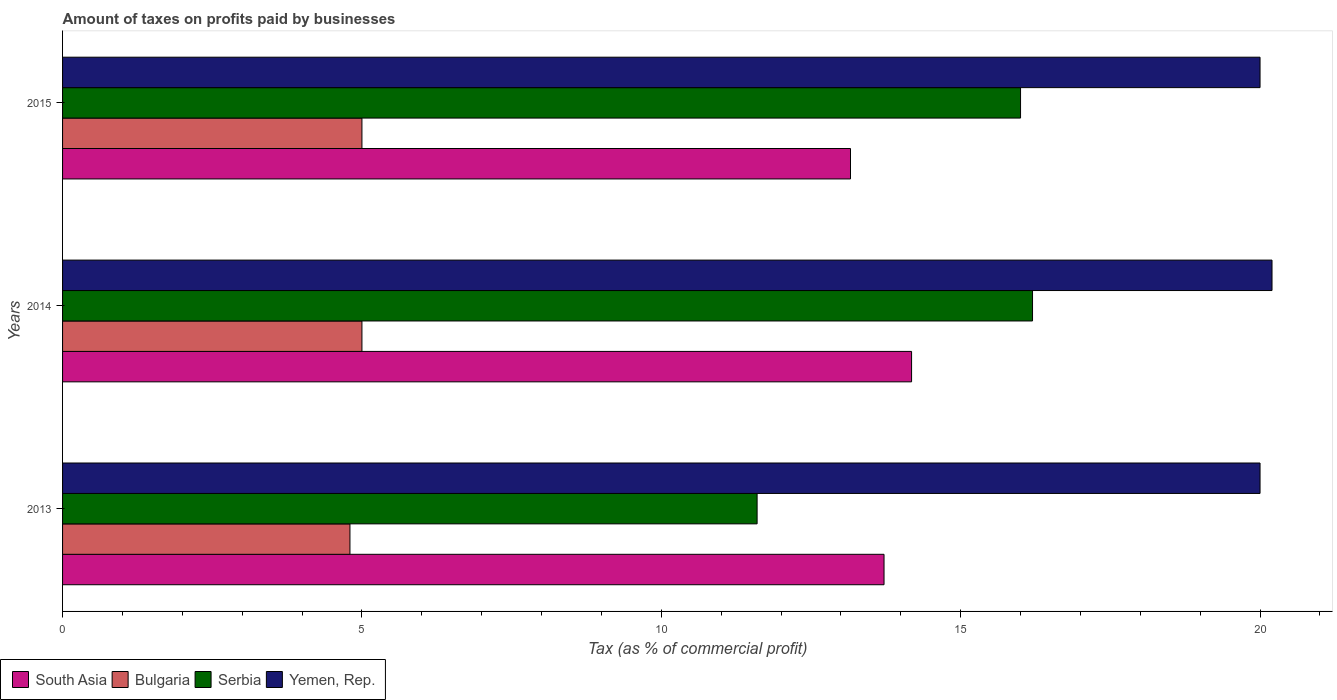How many different coloured bars are there?
Your response must be concise. 4. What is the label of the 1st group of bars from the top?
Ensure brevity in your answer.  2015. In how many cases, is the number of bars for a given year not equal to the number of legend labels?
Make the answer very short. 0. Across all years, what is the maximum percentage of taxes paid by businesses in Yemen, Rep.?
Your answer should be compact. 20.2. In which year was the percentage of taxes paid by businesses in South Asia minimum?
Make the answer very short. 2015. What is the difference between the percentage of taxes paid by businesses in Serbia in 2014 and that in 2015?
Your response must be concise. 0.2. What is the difference between the percentage of taxes paid by businesses in South Asia in 2014 and the percentage of taxes paid by businesses in Bulgaria in 2015?
Your response must be concise. 9.18. What is the average percentage of taxes paid by businesses in South Asia per year?
Give a very brief answer. 13.69. In the year 2013, what is the difference between the percentage of taxes paid by businesses in Serbia and percentage of taxes paid by businesses in South Asia?
Ensure brevity in your answer.  -2.12. What is the ratio of the percentage of taxes paid by businesses in Serbia in 2013 to that in 2014?
Make the answer very short. 0.72. Is the percentage of taxes paid by businesses in Bulgaria in 2013 less than that in 2014?
Your answer should be very brief. Yes. Is the difference between the percentage of taxes paid by businesses in Serbia in 2013 and 2015 greater than the difference between the percentage of taxes paid by businesses in South Asia in 2013 and 2015?
Your answer should be compact. No. What is the difference between the highest and the second highest percentage of taxes paid by businesses in South Asia?
Give a very brief answer. 0.46. What is the difference between the highest and the lowest percentage of taxes paid by businesses in Bulgaria?
Offer a very short reply. 0.2. In how many years, is the percentage of taxes paid by businesses in Bulgaria greater than the average percentage of taxes paid by businesses in Bulgaria taken over all years?
Keep it short and to the point. 2. Is the sum of the percentage of taxes paid by businesses in South Asia in 2013 and 2015 greater than the maximum percentage of taxes paid by businesses in Bulgaria across all years?
Offer a terse response. Yes. Is it the case that in every year, the sum of the percentage of taxes paid by businesses in South Asia and percentage of taxes paid by businesses in Bulgaria is greater than the sum of percentage of taxes paid by businesses in Serbia and percentage of taxes paid by businesses in Yemen, Rep.?
Offer a terse response. No. What does the 4th bar from the top in 2015 represents?
Make the answer very short. South Asia. What does the 2nd bar from the bottom in 2015 represents?
Keep it short and to the point. Bulgaria. Are all the bars in the graph horizontal?
Keep it short and to the point. Yes. How many years are there in the graph?
Give a very brief answer. 3. What is the difference between two consecutive major ticks on the X-axis?
Keep it short and to the point. 5. Does the graph contain any zero values?
Offer a very short reply. No. Where does the legend appear in the graph?
Provide a succinct answer. Bottom left. How are the legend labels stacked?
Offer a terse response. Horizontal. What is the title of the graph?
Offer a very short reply. Amount of taxes on profits paid by businesses. Does "Hungary" appear as one of the legend labels in the graph?
Make the answer very short. No. What is the label or title of the X-axis?
Provide a succinct answer. Tax (as % of commercial profit). What is the label or title of the Y-axis?
Ensure brevity in your answer.  Years. What is the Tax (as % of commercial profit) of South Asia in 2013?
Keep it short and to the point. 13.72. What is the Tax (as % of commercial profit) in Serbia in 2013?
Ensure brevity in your answer.  11.6. What is the Tax (as % of commercial profit) of South Asia in 2014?
Offer a terse response. 14.18. What is the Tax (as % of commercial profit) of Yemen, Rep. in 2014?
Make the answer very short. 20.2. What is the Tax (as % of commercial profit) in South Asia in 2015?
Ensure brevity in your answer.  13.16. What is the Tax (as % of commercial profit) in Bulgaria in 2015?
Make the answer very short. 5. Across all years, what is the maximum Tax (as % of commercial profit) of South Asia?
Your answer should be compact. 14.18. Across all years, what is the maximum Tax (as % of commercial profit) in Yemen, Rep.?
Keep it short and to the point. 20.2. Across all years, what is the minimum Tax (as % of commercial profit) of South Asia?
Keep it short and to the point. 13.16. What is the total Tax (as % of commercial profit) of South Asia in the graph?
Provide a short and direct response. 41.06. What is the total Tax (as % of commercial profit) of Serbia in the graph?
Make the answer very short. 43.8. What is the total Tax (as % of commercial profit) in Yemen, Rep. in the graph?
Offer a very short reply. 60.2. What is the difference between the Tax (as % of commercial profit) of South Asia in 2013 and that in 2014?
Keep it short and to the point. -0.46. What is the difference between the Tax (as % of commercial profit) of Yemen, Rep. in 2013 and that in 2014?
Keep it short and to the point. -0.2. What is the difference between the Tax (as % of commercial profit) of South Asia in 2013 and that in 2015?
Your answer should be compact. 0.56. What is the difference between the Tax (as % of commercial profit) in Bulgaria in 2013 and that in 2015?
Ensure brevity in your answer.  -0.2. What is the difference between the Tax (as % of commercial profit) of Serbia in 2013 and that in 2015?
Offer a terse response. -4.4. What is the difference between the Tax (as % of commercial profit) in South Asia in 2014 and that in 2015?
Keep it short and to the point. 1.02. What is the difference between the Tax (as % of commercial profit) of Serbia in 2014 and that in 2015?
Your answer should be very brief. 0.2. What is the difference between the Tax (as % of commercial profit) in Yemen, Rep. in 2014 and that in 2015?
Your answer should be compact. 0.2. What is the difference between the Tax (as % of commercial profit) of South Asia in 2013 and the Tax (as % of commercial profit) of Bulgaria in 2014?
Provide a short and direct response. 8.72. What is the difference between the Tax (as % of commercial profit) of South Asia in 2013 and the Tax (as % of commercial profit) of Serbia in 2014?
Keep it short and to the point. -2.48. What is the difference between the Tax (as % of commercial profit) of South Asia in 2013 and the Tax (as % of commercial profit) of Yemen, Rep. in 2014?
Your answer should be very brief. -6.48. What is the difference between the Tax (as % of commercial profit) in Bulgaria in 2013 and the Tax (as % of commercial profit) in Yemen, Rep. in 2014?
Your answer should be compact. -15.4. What is the difference between the Tax (as % of commercial profit) of Serbia in 2013 and the Tax (as % of commercial profit) of Yemen, Rep. in 2014?
Your response must be concise. -8.6. What is the difference between the Tax (as % of commercial profit) in South Asia in 2013 and the Tax (as % of commercial profit) in Bulgaria in 2015?
Keep it short and to the point. 8.72. What is the difference between the Tax (as % of commercial profit) in South Asia in 2013 and the Tax (as % of commercial profit) in Serbia in 2015?
Ensure brevity in your answer.  -2.28. What is the difference between the Tax (as % of commercial profit) of South Asia in 2013 and the Tax (as % of commercial profit) of Yemen, Rep. in 2015?
Provide a short and direct response. -6.28. What is the difference between the Tax (as % of commercial profit) in Bulgaria in 2013 and the Tax (as % of commercial profit) in Yemen, Rep. in 2015?
Your answer should be very brief. -15.2. What is the difference between the Tax (as % of commercial profit) in South Asia in 2014 and the Tax (as % of commercial profit) in Bulgaria in 2015?
Provide a succinct answer. 9.18. What is the difference between the Tax (as % of commercial profit) in South Asia in 2014 and the Tax (as % of commercial profit) in Serbia in 2015?
Provide a succinct answer. -1.82. What is the difference between the Tax (as % of commercial profit) in South Asia in 2014 and the Tax (as % of commercial profit) in Yemen, Rep. in 2015?
Ensure brevity in your answer.  -5.82. What is the difference between the Tax (as % of commercial profit) in Bulgaria in 2014 and the Tax (as % of commercial profit) in Serbia in 2015?
Make the answer very short. -11. What is the average Tax (as % of commercial profit) of South Asia per year?
Provide a succinct answer. 13.69. What is the average Tax (as % of commercial profit) in Bulgaria per year?
Your answer should be compact. 4.93. What is the average Tax (as % of commercial profit) of Yemen, Rep. per year?
Give a very brief answer. 20.07. In the year 2013, what is the difference between the Tax (as % of commercial profit) of South Asia and Tax (as % of commercial profit) of Bulgaria?
Make the answer very short. 8.92. In the year 2013, what is the difference between the Tax (as % of commercial profit) of South Asia and Tax (as % of commercial profit) of Serbia?
Offer a very short reply. 2.12. In the year 2013, what is the difference between the Tax (as % of commercial profit) in South Asia and Tax (as % of commercial profit) in Yemen, Rep.?
Offer a terse response. -6.28. In the year 2013, what is the difference between the Tax (as % of commercial profit) in Bulgaria and Tax (as % of commercial profit) in Yemen, Rep.?
Offer a terse response. -15.2. In the year 2014, what is the difference between the Tax (as % of commercial profit) of South Asia and Tax (as % of commercial profit) of Bulgaria?
Offer a very short reply. 9.18. In the year 2014, what is the difference between the Tax (as % of commercial profit) in South Asia and Tax (as % of commercial profit) in Serbia?
Your answer should be very brief. -2.02. In the year 2014, what is the difference between the Tax (as % of commercial profit) in South Asia and Tax (as % of commercial profit) in Yemen, Rep.?
Offer a terse response. -6.02. In the year 2014, what is the difference between the Tax (as % of commercial profit) in Bulgaria and Tax (as % of commercial profit) in Serbia?
Offer a very short reply. -11.2. In the year 2014, what is the difference between the Tax (as % of commercial profit) of Bulgaria and Tax (as % of commercial profit) of Yemen, Rep.?
Give a very brief answer. -15.2. In the year 2015, what is the difference between the Tax (as % of commercial profit) of South Asia and Tax (as % of commercial profit) of Bulgaria?
Provide a short and direct response. 8.16. In the year 2015, what is the difference between the Tax (as % of commercial profit) of South Asia and Tax (as % of commercial profit) of Serbia?
Your answer should be very brief. -2.84. In the year 2015, what is the difference between the Tax (as % of commercial profit) in South Asia and Tax (as % of commercial profit) in Yemen, Rep.?
Provide a succinct answer. -6.84. What is the ratio of the Tax (as % of commercial profit) of South Asia in 2013 to that in 2014?
Provide a short and direct response. 0.97. What is the ratio of the Tax (as % of commercial profit) in Bulgaria in 2013 to that in 2014?
Make the answer very short. 0.96. What is the ratio of the Tax (as % of commercial profit) of Serbia in 2013 to that in 2014?
Make the answer very short. 0.72. What is the ratio of the Tax (as % of commercial profit) in South Asia in 2013 to that in 2015?
Keep it short and to the point. 1.04. What is the ratio of the Tax (as % of commercial profit) of Serbia in 2013 to that in 2015?
Offer a terse response. 0.72. What is the ratio of the Tax (as % of commercial profit) of Yemen, Rep. in 2013 to that in 2015?
Offer a very short reply. 1. What is the ratio of the Tax (as % of commercial profit) in South Asia in 2014 to that in 2015?
Keep it short and to the point. 1.08. What is the ratio of the Tax (as % of commercial profit) in Serbia in 2014 to that in 2015?
Make the answer very short. 1.01. What is the difference between the highest and the second highest Tax (as % of commercial profit) in South Asia?
Offer a terse response. 0.46. What is the difference between the highest and the second highest Tax (as % of commercial profit) of Serbia?
Offer a very short reply. 0.2. What is the difference between the highest and the second highest Tax (as % of commercial profit) of Yemen, Rep.?
Your answer should be compact. 0.2. What is the difference between the highest and the lowest Tax (as % of commercial profit) of Serbia?
Your answer should be compact. 4.6. What is the difference between the highest and the lowest Tax (as % of commercial profit) in Yemen, Rep.?
Make the answer very short. 0.2. 